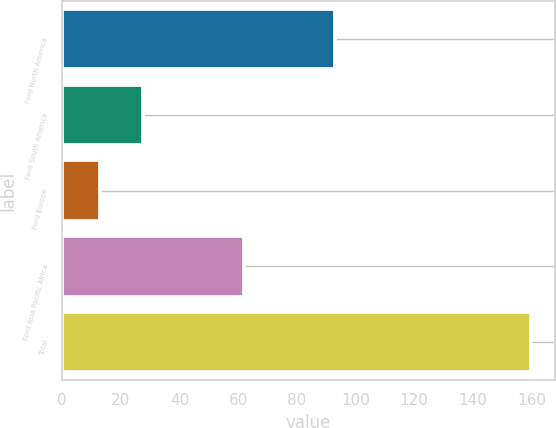<chart> <loc_0><loc_0><loc_500><loc_500><bar_chart><fcel>Ford North America<fcel>Ford South America<fcel>Ford Europe<fcel>Ford Asia Pacific Africa<fcel>Total<nl><fcel>93<fcel>27.7<fcel>13<fcel>62<fcel>160<nl></chart> 